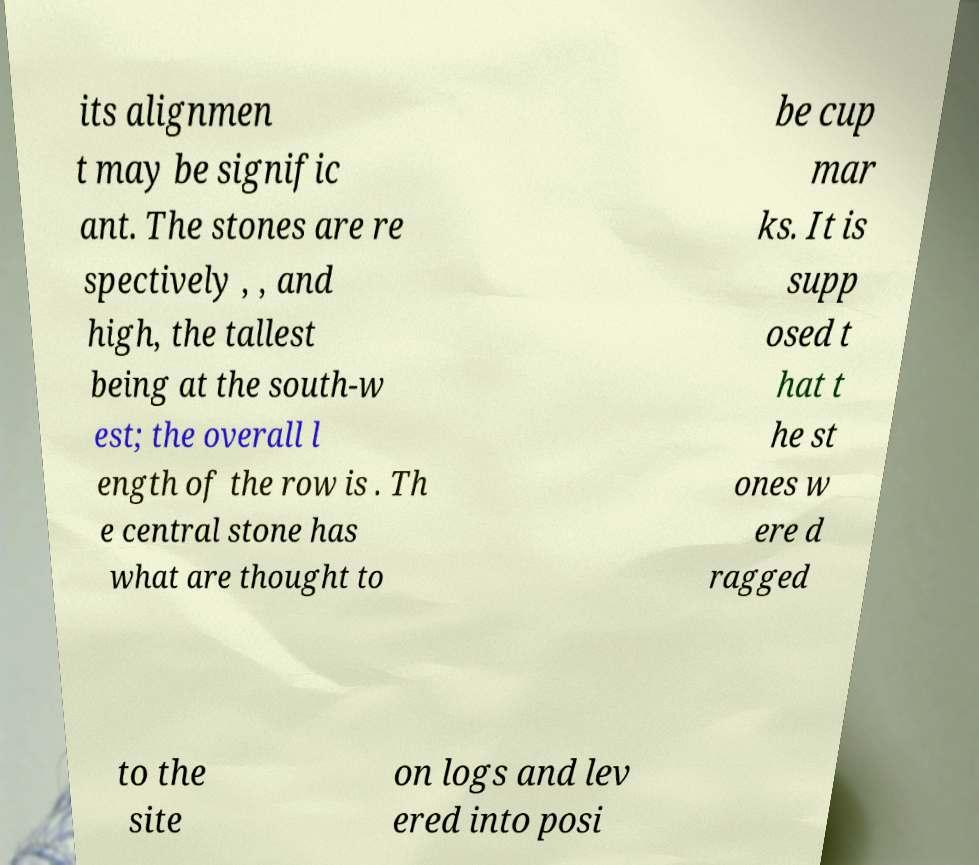Can you read and provide the text displayed in the image?This photo seems to have some interesting text. Can you extract and type it out for me? its alignmen t may be signific ant. The stones are re spectively , , and high, the tallest being at the south-w est; the overall l ength of the row is . Th e central stone has what are thought to be cup mar ks. It is supp osed t hat t he st ones w ere d ragged to the site on logs and lev ered into posi 